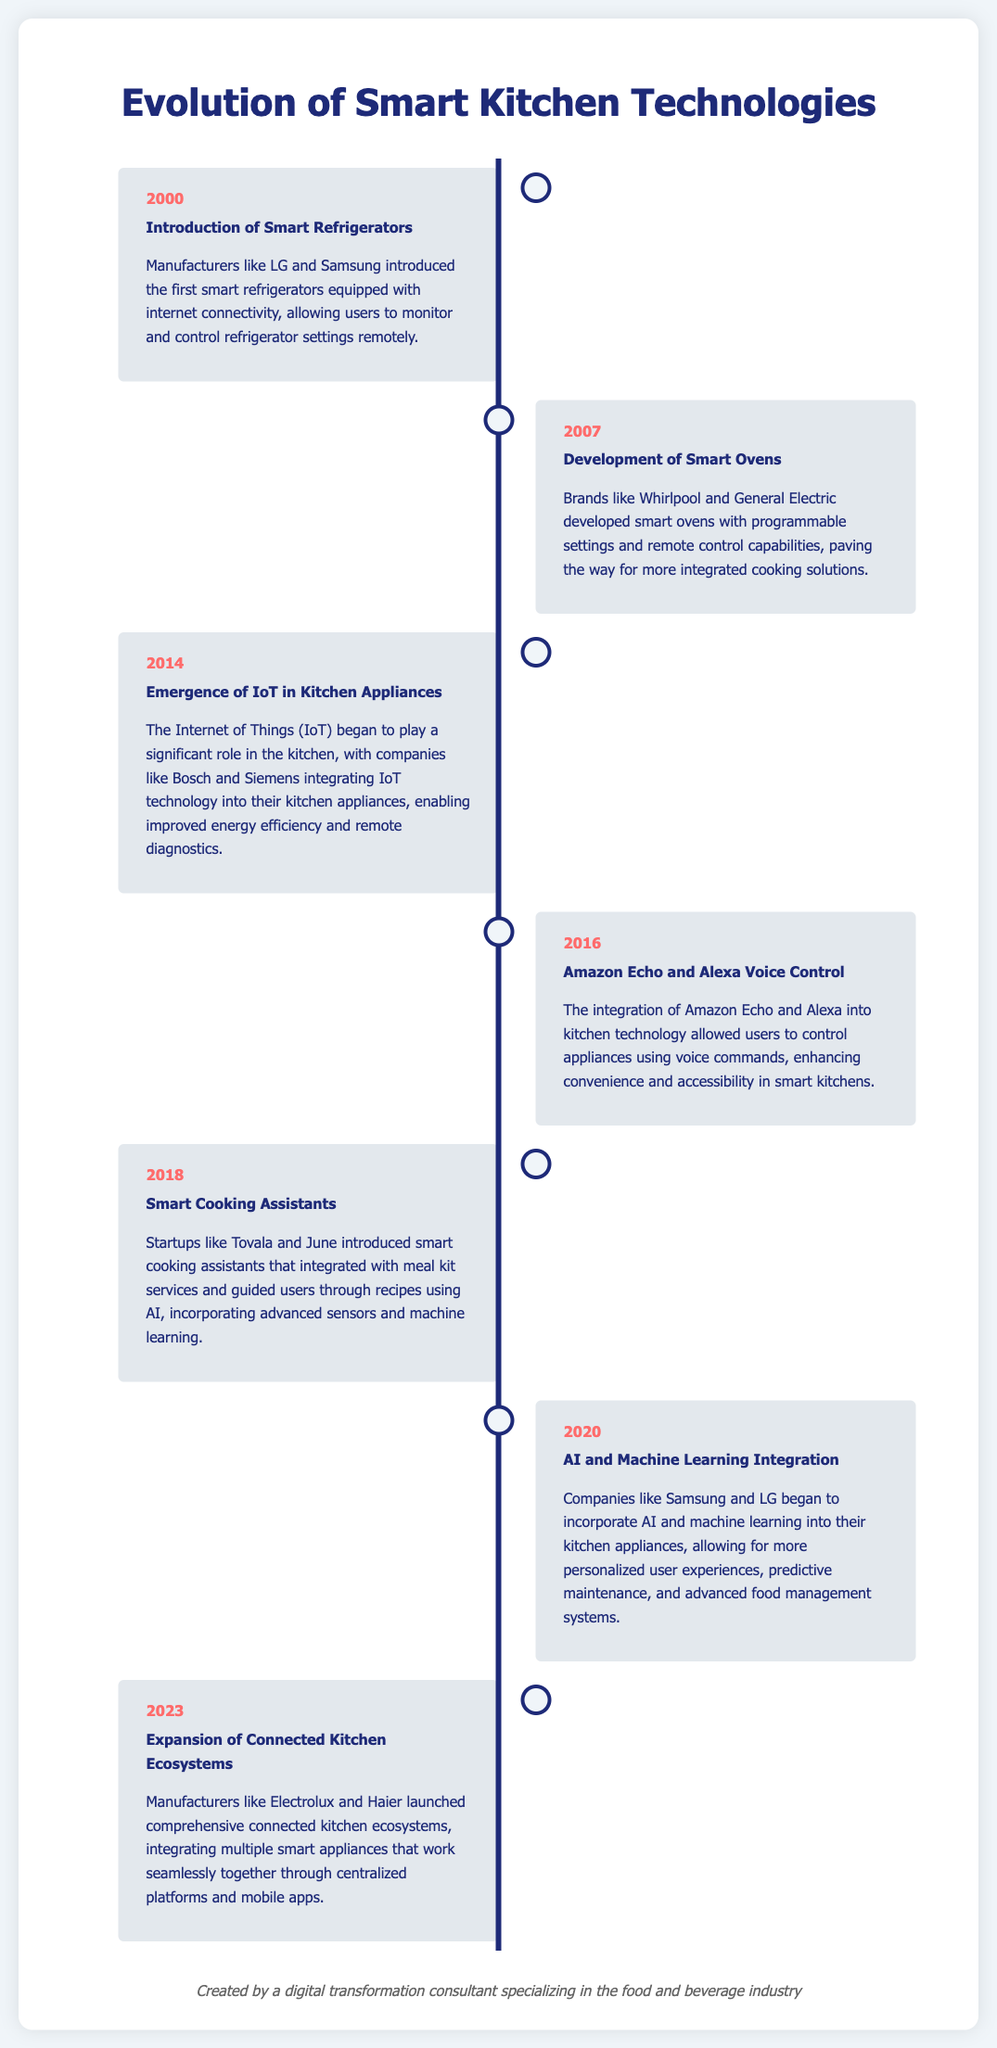What year did smart refrigerators first get introduced? The document states that smart refrigerators were introduced in the year 2000.
Answer: 2000 Which company developed smart ovens in 2007? The document mentions that brands like Whirlpool and General Electric developed smart ovens in 2007.
Answer: Whirlpool and General Electric What significant integration occurred in 2014 concerning kitchen appliances? The document highlights the emergence of IoT in kitchen appliances during 2014.
Answer: IoT Which voice-controlled device was integrated into kitchen technology in 2016? The document indicates that Amazon Echo and Alexa were integrated into kitchen technology in 2016.
Answer: Amazon Echo and Alexa What advancement in kitchen technologies was introduced by startups like Tovala in 2018? The document refers to the introduction of smart cooking assistants by startups like Tovala in 2018.
Answer: Smart cooking assistants Which year saw the incorporation of AI and machine learning into kitchen appliances? The document mentions that AI and machine learning integration in kitchen appliances began in 2020.
Answer: 2020 What term describes the comprehensive systems launched by manufacturers like Electrolux in 2023? The document describes these as connected kitchen ecosystems in 2023.
Answer: Connected kitchen ecosystems What role did companies like Bosch and Siemens play in 2014? The document indicates that they integrated IoT technology into their kitchen appliances.
Answer: Integrated IoT technology Why is 2016 a notable year in the evolution of smart kitchen technologies? The document highlights that it was the year when voice control was integrated into kitchen technology.
Answer: Voice control integration 